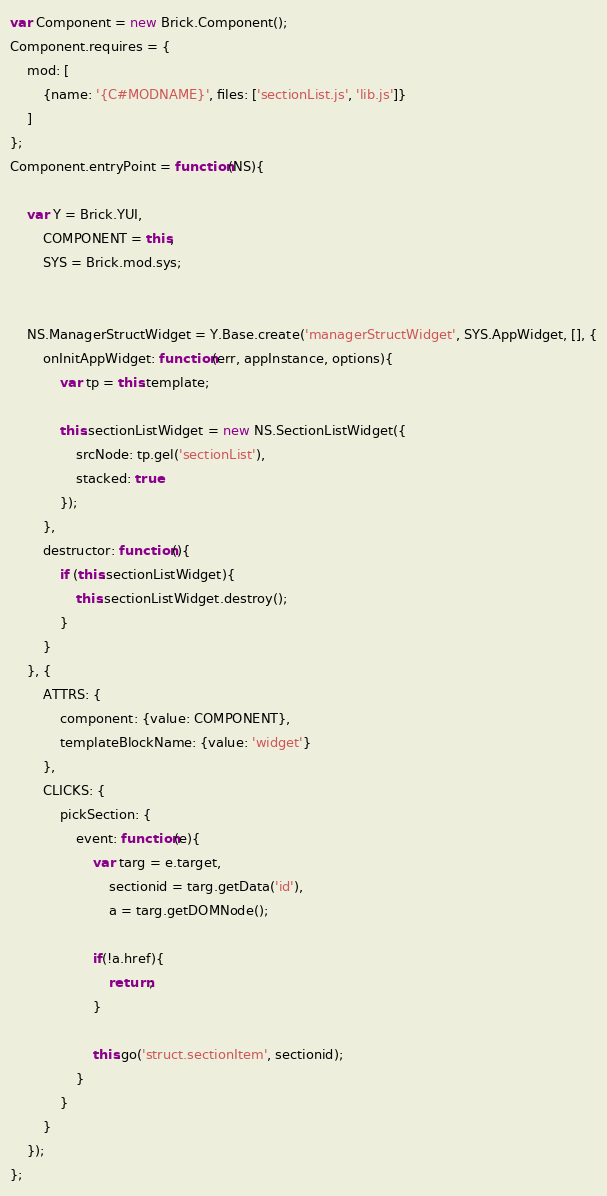Convert code to text. <code><loc_0><loc_0><loc_500><loc_500><_JavaScript_>var Component = new Brick.Component();
Component.requires = {
    mod: [
        {name: '{C#MODNAME}', files: ['sectionList.js', 'lib.js']}
    ]
};
Component.entryPoint = function(NS){

    var Y = Brick.YUI,
        COMPONENT = this,
        SYS = Brick.mod.sys;
   
    
    NS.ManagerStructWidget = Y.Base.create('managerStructWidget', SYS.AppWidget, [], {
        onInitAppWidget: function(err, appInstance, options){
            var tp = this.template;
            
            this.sectionListWidget = new NS.SectionListWidget({
                srcNode: tp.gel('sectionList'),
                stacked: true
            });
        },
        destructor: function(){
            if (this.sectionListWidget){
                this.sectionListWidget.destroy();
            }
        }
    }, {
        ATTRS: {
            component: {value: COMPONENT},
            templateBlockName: {value: 'widget'}
        },
        CLICKS: {
        	pickSection: {
        		event: function(e){
        			var targ = e.target,
        				sectionid = targ.getData('id'),
        				a = targ.getDOMNode();
        			
        			if(!a.href){
        				return;
        			}
        			
        			this.go('struct.sectionItem', sectionid);
        		}
        	}
        }
    });
};</code> 